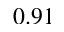Convert formula to latex. <formula><loc_0><loc_0><loc_500><loc_500>0 . 9 1</formula> 